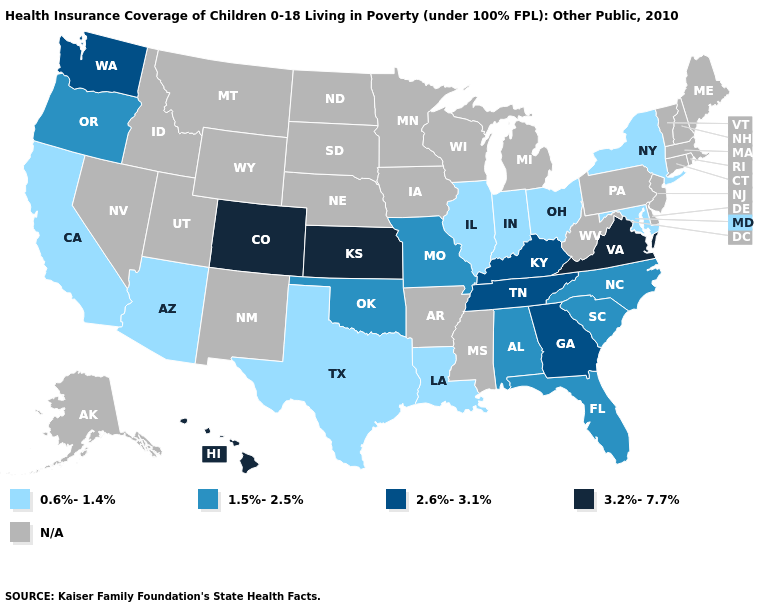Name the states that have a value in the range N/A?
Short answer required. Alaska, Arkansas, Connecticut, Delaware, Idaho, Iowa, Maine, Massachusetts, Michigan, Minnesota, Mississippi, Montana, Nebraska, Nevada, New Hampshire, New Jersey, New Mexico, North Dakota, Pennsylvania, Rhode Island, South Dakota, Utah, Vermont, West Virginia, Wisconsin, Wyoming. Does the map have missing data?
Keep it brief. Yes. Name the states that have a value in the range 0.6%-1.4%?
Quick response, please. Arizona, California, Illinois, Indiana, Louisiana, Maryland, New York, Ohio, Texas. Name the states that have a value in the range 0.6%-1.4%?
Answer briefly. Arizona, California, Illinois, Indiana, Louisiana, Maryland, New York, Ohio, Texas. What is the value of Iowa?
Keep it brief. N/A. Does the first symbol in the legend represent the smallest category?
Write a very short answer. Yes. What is the value of Georgia?
Keep it brief. 2.6%-3.1%. Name the states that have a value in the range 0.6%-1.4%?
Give a very brief answer. Arizona, California, Illinois, Indiana, Louisiana, Maryland, New York, Ohio, Texas. How many symbols are there in the legend?
Short answer required. 5. What is the value of Colorado?
Quick response, please. 3.2%-7.7%. What is the value of Texas?
Answer briefly. 0.6%-1.4%. Among the states that border Georgia , does Tennessee have the lowest value?
Keep it brief. No. 